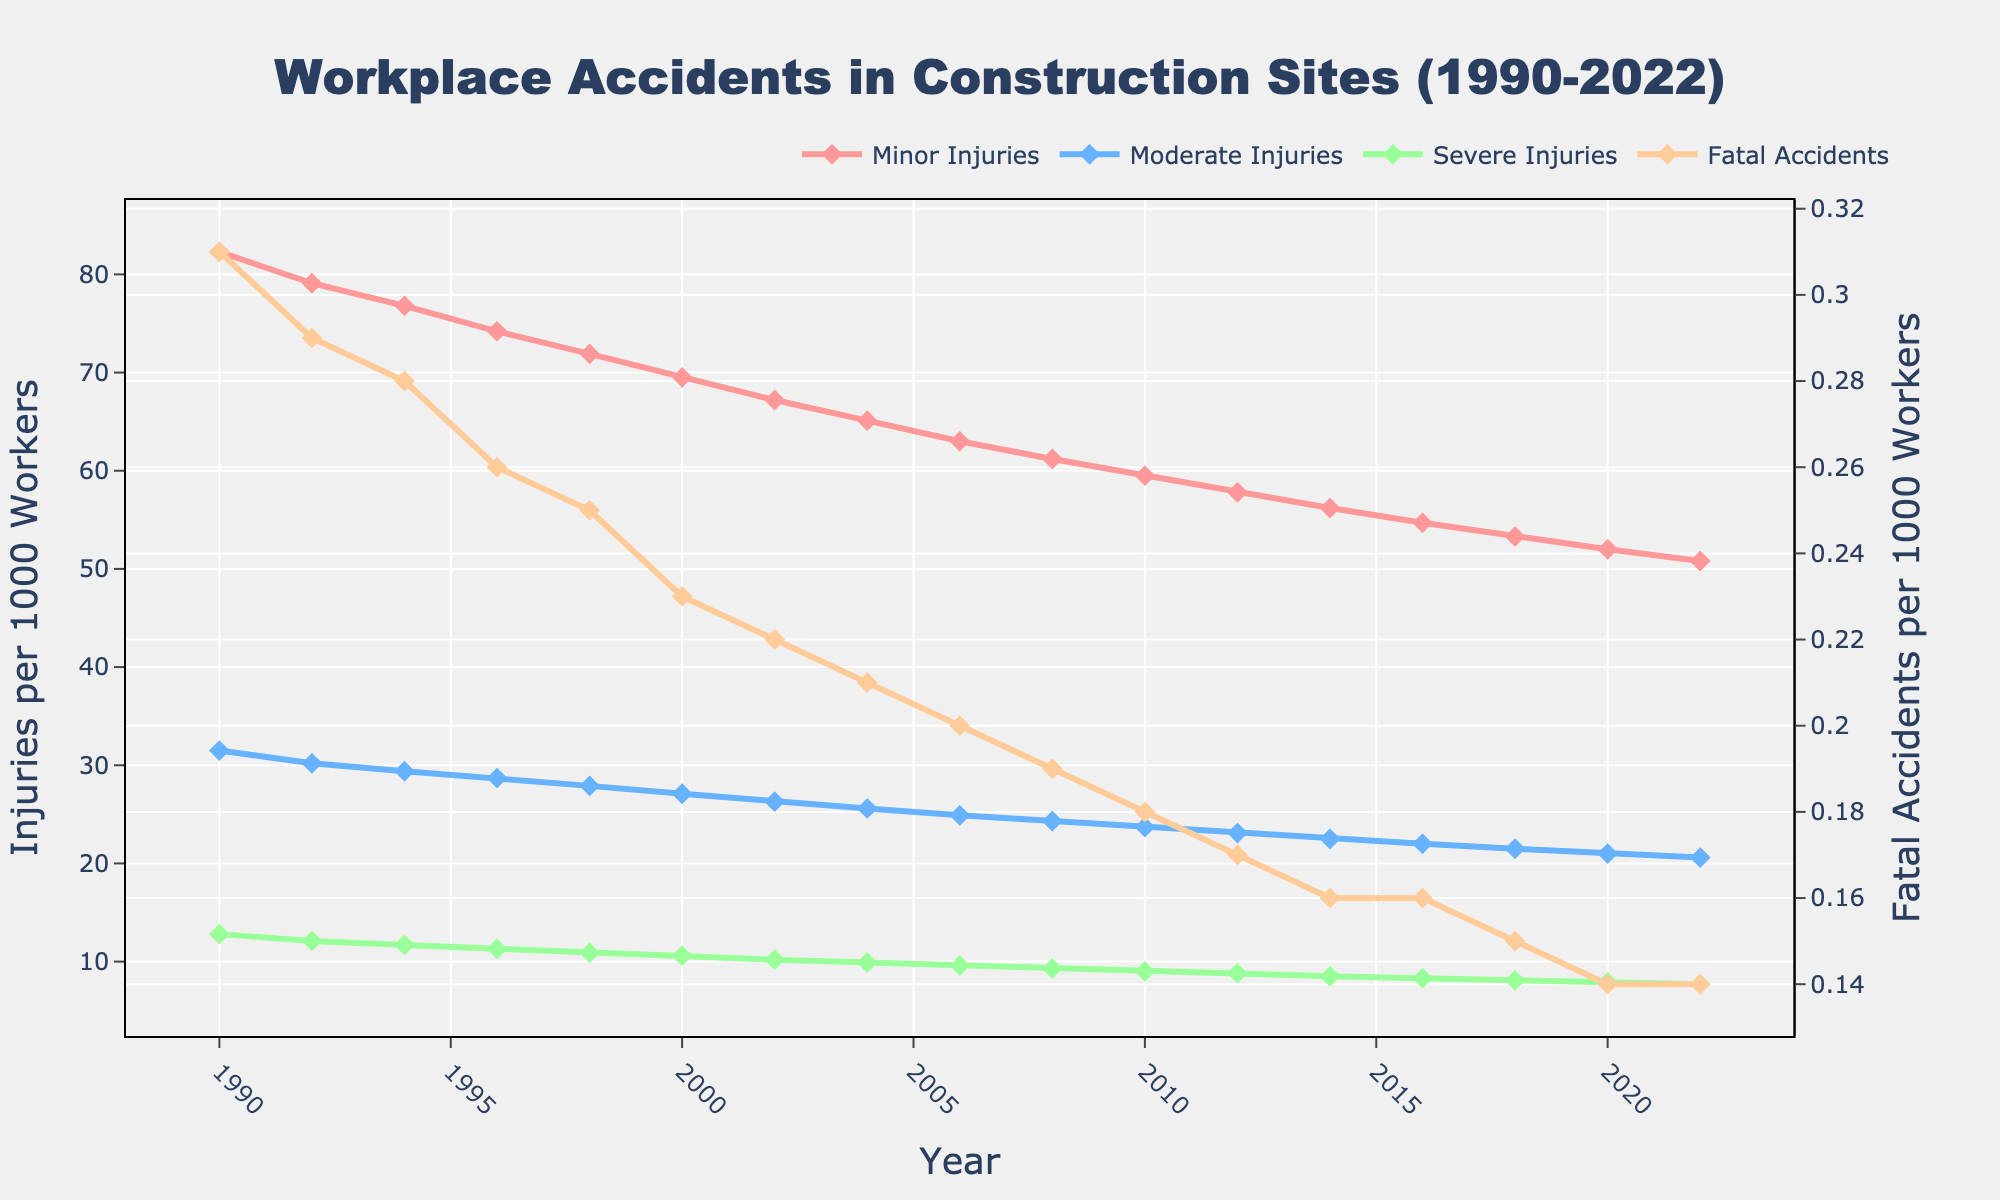What is the overall trend in the number of minor injuries from 1990 to 2022? To determine the overall trend, observe the line for Minor Injuries from 1990 to 2022. The numbers decrease from 82.3 in 1990 to 50.8 in 2022. Therefore, the trend is a decline.
Answer: Declining Which year had the highest number of moderate injuries? By examining the Moderate Injuries line, we see that it starts at 31.5 in 1990 and generally decreases. 1990 has the highest value.
Answer: 1990 How much did the rate of severe injuries decrease from 1990 to 2022? Look at the Severe Injuries values for 1990 and 2022. In 1990, it was 12.8; in 2022, it was 7.7. The change is 12.8 - 7.7.
Answer: 5.1 In which year did fatal accidents drop below 0.2 per 1000 workers for the first time? Check the Fatal Accidents category values across the years. It goes below 0.2 for the first time in 2008, where it is 0.19.
Answer: 2008 How did the number of moderate injuries change between 2000 and 2010? Look at the values for Moderate Injuries in 2000 and 2010. It's 27.1 in 2000 and 23.7 in 2010. The change is 27.1 - 23.7.
Answer: Decreased by 3.4 Compare the rates of minor and moderate injuries in 2014. Which is higher? In 2014, Minor Injuries are 56.2, and Moderate Injuries are 22.5. Since 56.2 is greater than 22.5, Minor Injuries are higher.
Answer: Minor Injuries What is the difference between the number of Minor Injuries and Severe Injuries in 1998? For 1998, Minor Injuries are 71.9, and Severe Injuries are 10.9. The difference is 71.9 - 10.9.
Answer: 61 Which injury type shows the least variation in its numbers over the years? Observe the lines for each injury type. Fatal Accidents show very little variation, remaining close to 0.31 and ending at 0.14.
Answer: Fatal Accidents What is the average rate of severe injuries over the period? Add all the severe injuries values and divide by the number of data points (9). Total is (12.8 + 12.1 + 11.7 + 11.3 + 10.9 + 10.6 + 10.2 + 9.9 + 9.6 + 9.3 + 9.0 + 8.8 + 8.5 + 8.3 + 8.1 + 7.9 + 7.7) = 158.8. Average is 158.8 / 17.
Answer: 9.34 